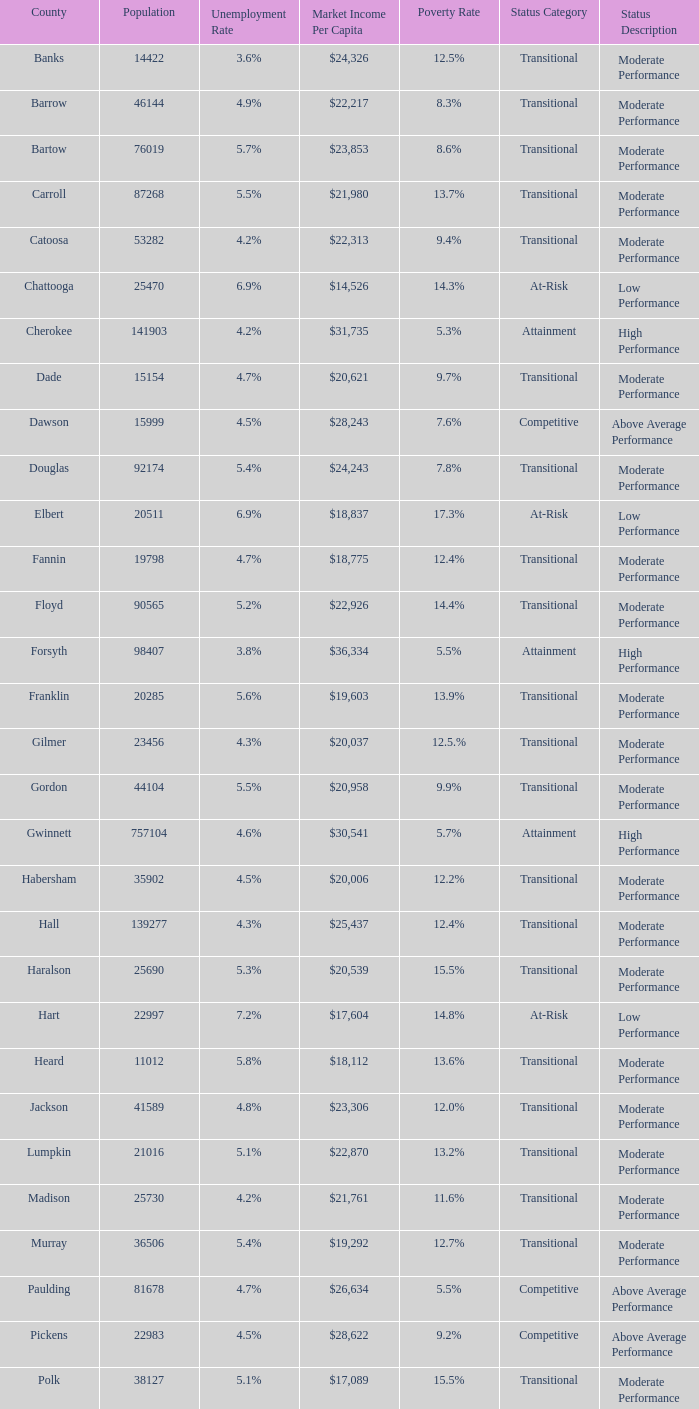What is the market income per capita of the county with the 9.4% poverty rate? $22,313. 